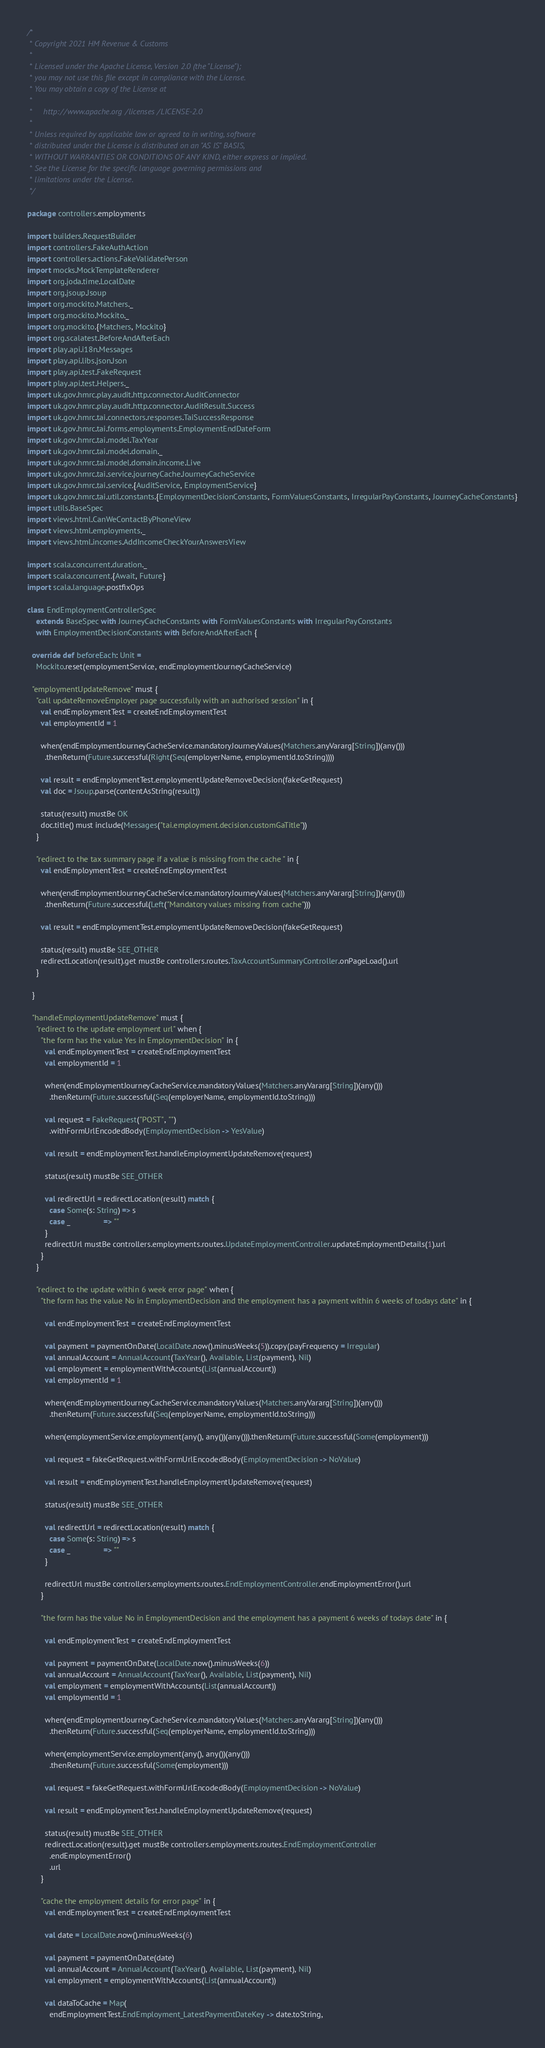Convert code to text. <code><loc_0><loc_0><loc_500><loc_500><_Scala_>/*
 * Copyright 2021 HM Revenue & Customs
 *
 * Licensed under the Apache License, Version 2.0 (the "License");
 * you may not use this file except in compliance with the License.
 * You may obtain a copy of the License at
 *
 *     http://www.apache.org/licenses/LICENSE-2.0
 *
 * Unless required by applicable law or agreed to in writing, software
 * distributed under the License is distributed on an "AS IS" BASIS,
 * WITHOUT WARRANTIES OR CONDITIONS OF ANY KIND, either express or implied.
 * See the License for the specific language governing permissions and
 * limitations under the License.
 */

package controllers.employments

import builders.RequestBuilder
import controllers.FakeAuthAction
import controllers.actions.FakeValidatePerson
import mocks.MockTemplateRenderer
import org.joda.time.LocalDate
import org.jsoup.Jsoup
import org.mockito.Matchers._
import org.mockito.Mockito._
import org.mockito.{Matchers, Mockito}
import org.scalatest.BeforeAndAfterEach
import play.api.i18n.Messages
import play.api.libs.json.Json
import play.api.test.FakeRequest
import play.api.test.Helpers._
import uk.gov.hmrc.play.audit.http.connector.AuditConnector
import uk.gov.hmrc.play.audit.http.connector.AuditResult.Success
import uk.gov.hmrc.tai.connectors.responses.TaiSuccessResponse
import uk.gov.hmrc.tai.forms.employments.EmploymentEndDateForm
import uk.gov.hmrc.tai.model.TaxYear
import uk.gov.hmrc.tai.model.domain._
import uk.gov.hmrc.tai.model.domain.income.Live
import uk.gov.hmrc.tai.service.journeyCache.JourneyCacheService
import uk.gov.hmrc.tai.service.{AuditService, EmploymentService}
import uk.gov.hmrc.tai.util.constants.{EmploymentDecisionConstants, FormValuesConstants, IrregularPayConstants, JourneyCacheConstants}
import utils.BaseSpec
import views.html.CanWeContactByPhoneView
import views.html.employments._
import views.html.incomes.AddIncomeCheckYourAnswersView

import scala.concurrent.duration._
import scala.concurrent.{Await, Future}
import scala.language.postfixOps

class EndEmploymentControllerSpec
    extends BaseSpec with JourneyCacheConstants with FormValuesConstants with IrregularPayConstants
    with EmploymentDecisionConstants with BeforeAndAfterEach {

  override def beforeEach: Unit =
    Mockito.reset(employmentService, endEmploymentJourneyCacheService)

  "employmentUpdateRemove" must {
    "call updateRemoveEmployer page successfully with an authorised session" in {
      val endEmploymentTest = createEndEmploymentTest
      val employmentId = 1

      when(endEmploymentJourneyCacheService.mandatoryJourneyValues(Matchers.anyVararg[String])(any()))
        .thenReturn(Future.successful(Right(Seq(employerName, employmentId.toString))))

      val result = endEmploymentTest.employmentUpdateRemoveDecision(fakeGetRequest)
      val doc = Jsoup.parse(contentAsString(result))

      status(result) mustBe OK
      doc.title() must include(Messages("tai.employment.decision.customGaTitle"))
    }

    "redirect to the tax summary page if a value is missing from the cache " in {
      val endEmploymentTest = createEndEmploymentTest

      when(endEmploymentJourneyCacheService.mandatoryJourneyValues(Matchers.anyVararg[String])(any()))
        .thenReturn(Future.successful(Left("Mandatory values missing from cache")))

      val result = endEmploymentTest.employmentUpdateRemoveDecision(fakeGetRequest)

      status(result) mustBe SEE_OTHER
      redirectLocation(result).get mustBe controllers.routes.TaxAccountSummaryController.onPageLoad().url
    }

  }

  "handleEmploymentUpdateRemove" must {
    "redirect to the update employment url" when {
      "the form has the value Yes in EmploymentDecision" in {
        val endEmploymentTest = createEndEmploymentTest
        val employmentId = 1

        when(endEmploymentJourneyCacheService.mandatoryValues(Matchers.anyVararg[String])(any()))
          .thenReturn(Future.successful(Seq(employerName, employmentId.toString)))

        val request = FakeRequest("POST", "")
          .withFormUrlEncodedBody(EmploymentDecision -> YesValue)

        val result = endEmploymentTest.handleEmploymentUpdateRemove(request)

        status(result) mustBe SEE_OTHER

        val redirectUrl = redirectLocation(result) match {
          case Some(s: String) => s
          case _               => ""
        }
        redirectUrl mustBe controllers.employments.routes.UpdateEmploymentController.updateEmploymentDetails(1).url
      }
    }

    "redirect to the update within 6 week error page" when {
      "the form has the value No in EmploymentDecision and the employment has a payment within 6 weeks of todays date" in {

        val endEmploymentTest = createEndEmploymentTest

        val payment = paymentOnDate(LocalDate.now().minusWeeks(5)).copy(payFrequency = Irregular)
        val annualAccount = AnnualAccount(TaxYear(), Available, List(payment), Nil)
        val employment = employmentWithAccounts(List(annualAccount))
        val employmentId = 1

        when(endEmploymentJourneyCacheService.mandatoryValues(Matchers.anyVararg[String])(any()))
          .thenReturn(Future.successful(Seq(employerName, employmentId.toString)))

        when(employmentService.employment(any(), any())(any())).thenReturn(Future.successful(Some(employment)))

        val request = fakeGetRequest.withFormUrlEncodedBody(EmploymentDecision -> NoValue)

        val result = endEmploymentTest.handleEmploymentUpdateRemove(request)

        status(result) mustBe SEE_OTHER

        val redirectUrl = redirectLocation(result) match {
          case Some(s: String) => s
          case _               => ""
        }

        redirectUrl mustBe controllers.employments.routes.EndEmploymentController.endEmploymentError().url
      }

      "the form has the value No in EmploymentDecision and the employment has a payment 6 weeks of todays date" in {

        val endEmploymentTest = createEndEmploymentTest

        val payment = paymentOnDate(LocalDate.now().minusWeeks(6))
        val annualAccount = AnnualAccount(TaxYear(), Available, List(payment), Nil)
        val employment = employmentWithAccounts(List(annualAccount))
        val employmentId = 1

        when(endEmploymentJourneyCacheService.mandatoryValues(Matchers.anyVararg[String])(any()))
          .thenReturn(Future.successful(Seq(employerName, employmentId.toString)))

        when(employmentService.employment(any(), any())(any()))
          .thenReturn(Future.successful(Some(employment)))

        val request = fakeGetRequest.withFormUrlEncodedBody(EmploymentDecision -> NoValue)

        val result = endEmploymentTest.handleEmploymentUpdateRemove(request)

        status(result) mustBe SEE_OTHER
        redirectLocation(result).get mustBe controllers.employments.routes.EndEmploymentController
          .endEmploymentError()
          .url
      }

      "cache the employment details for error page" in {
        val endEmploymentTest = createEndEmploymentTest

        val date = LocalDate.now().minusWeeks(6)

        val payment = paymentOnDate(date)
        val annualAccount = AnnualAccount(TaxYear(), Available, List(payment), Nil)
        val employment = employmentWithAccounts(List(annualAccount))

        val dataToCache = Map(
          endEmploymentTest.EndEmployment_LatestPaymentDateKey -> date.toString,</code> 